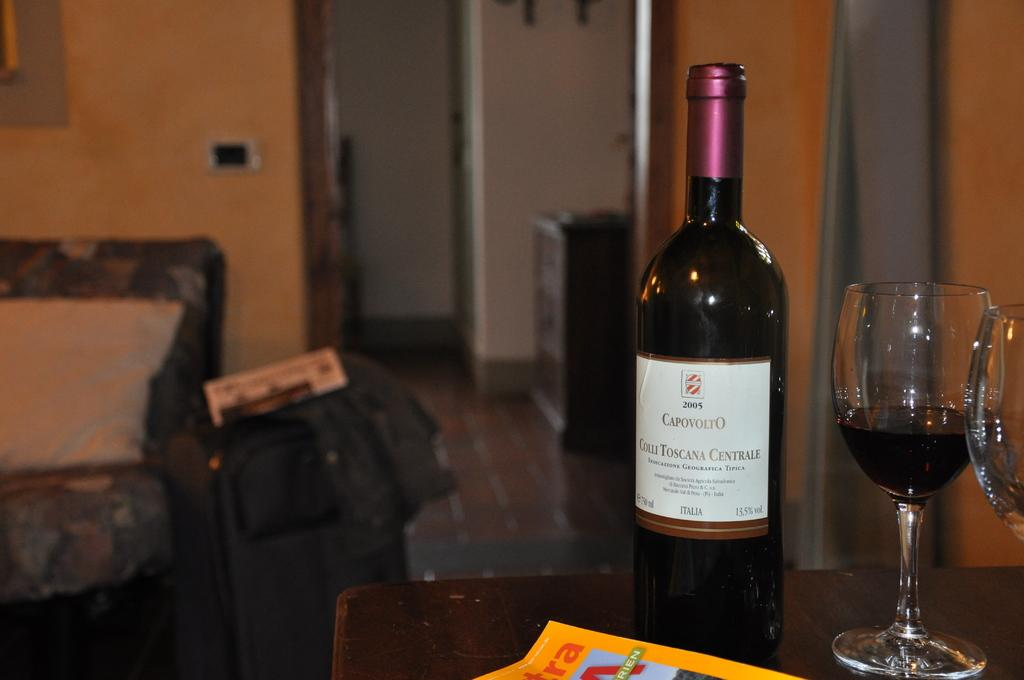<image>
Create a compact narrative representing the image presented. A bottle of wine that says 2005 CapovoltO on the label sits on a table beside a wine glass. 